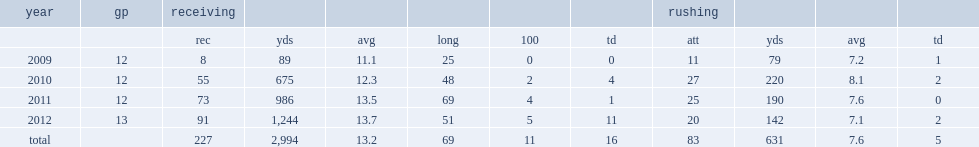How many receptions did markus wheaton record totally? 227.0. 